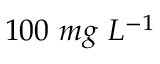<formula> <loc_0><loc_0><loc_500><loc_500>1 0 0 \ m g \ L ^ { - 1 }</formula> 